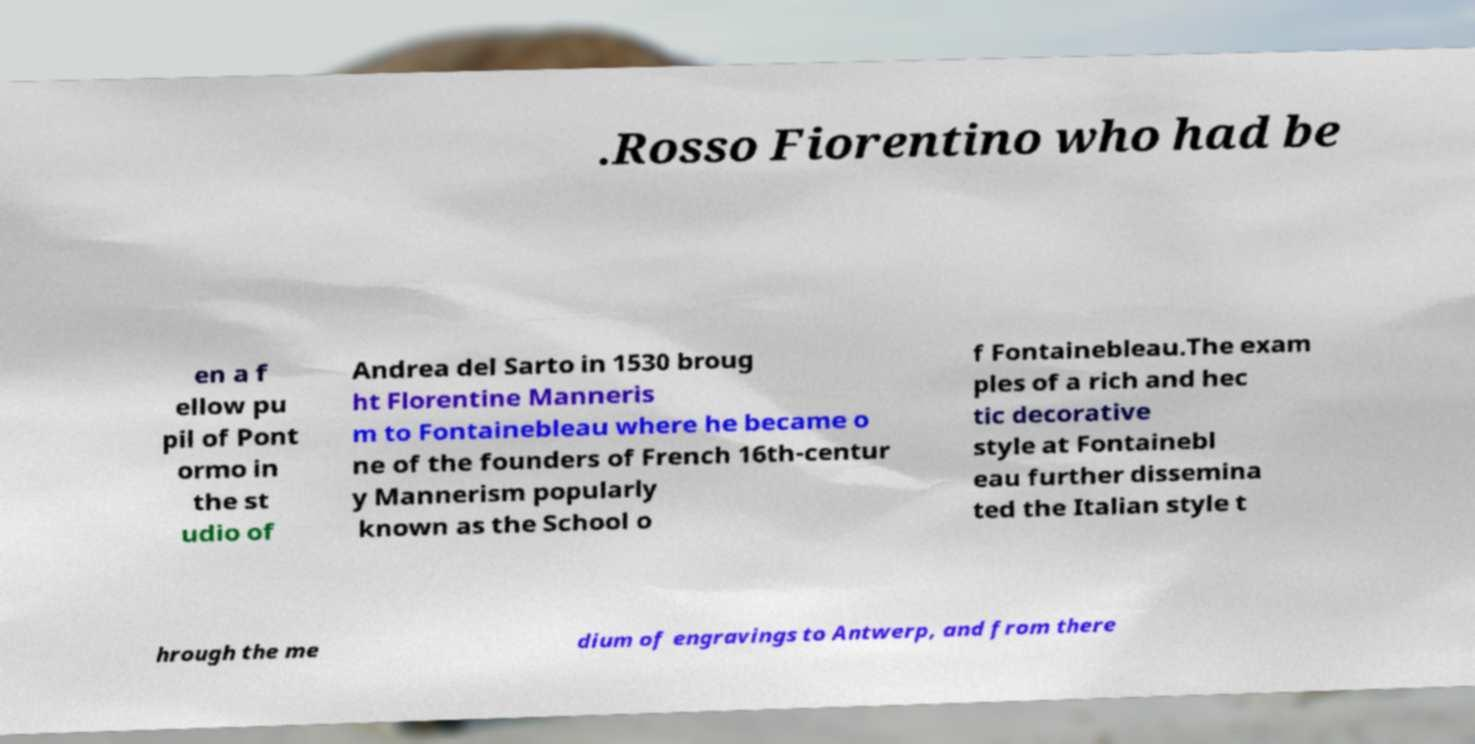Could you assist in decoding the text presented in this image and type it out clearly? .Rosso Fiorentino who had be en a f ellow pu pil of Pont ormo in the st udio of Andrea del Sarto in 1530 broug ht Florentine Manneris m to Fontainebleau where he became o ne of the founders of French 16th-centur y Mannerism popularly known as the School o f Fontainebleau.The exam ples of a rich and hec tic decorative style at Fontainebl eau further dissemina ted the Italian style t hrough the me dium of engravings to Antwerp, and from there 